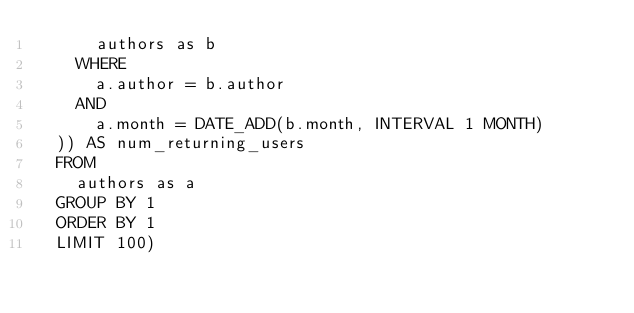Convert code to text. <code><loc_0><loc_0><loc_500><loc_500><_SQL_>      authors as b
    WHERE
      a.author = b.author
    AND
      a.month = DATE_ADD(b.month, INTERVAL 1 MONTH)
  )) AS num_returning_users
  FROM
    authors as a
  GROUP BY 1
  ORDER BY 1
  LIMIT 100)
</code> 